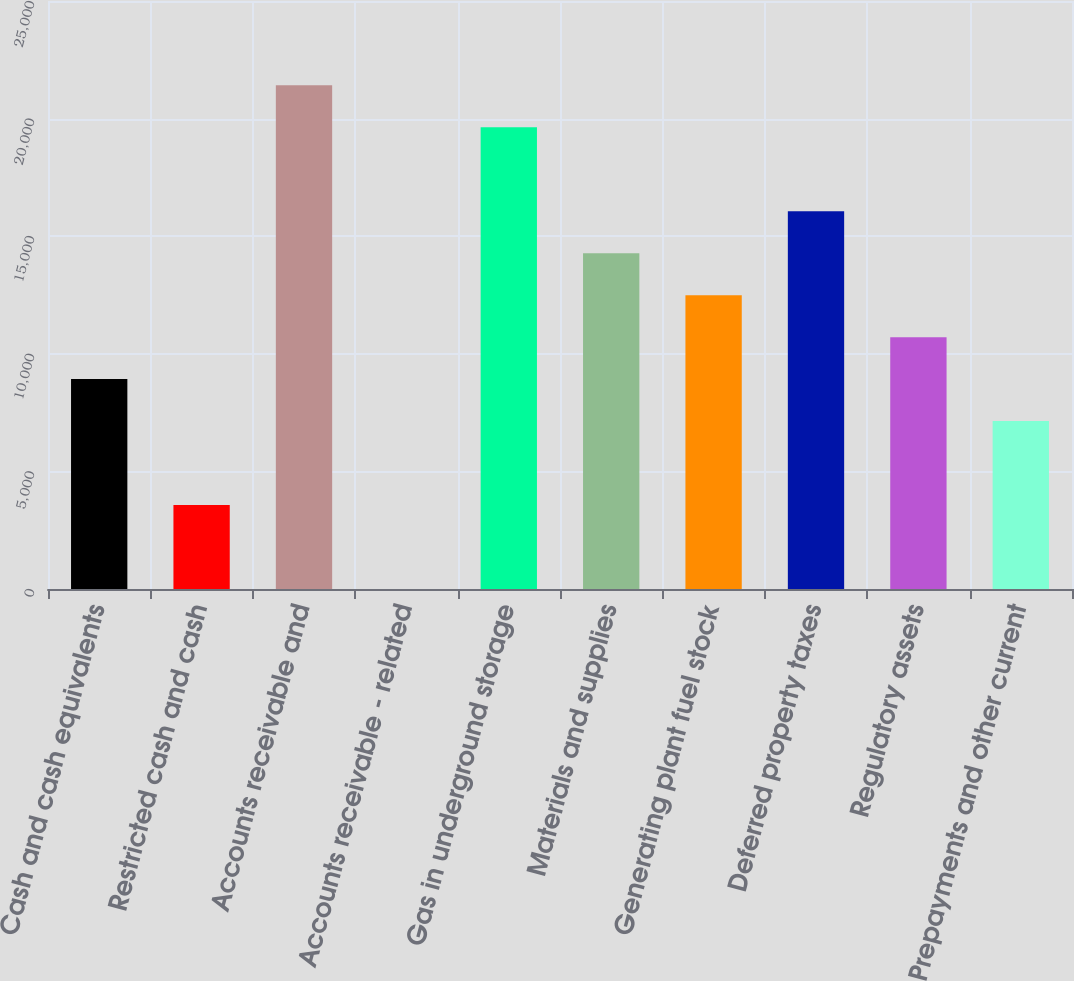Convert chart to OTSL. <chart><loc_0><loc_0><loc_500><loc_500><bar_chart><fcel>Cash and cash equivalents<fcel>Restricted cash and cash<fcel>Accounts receivable and<fcel>Accounts receivable - related<fcel>Gas in underground storage<fcel>Materials and supplies<fcel>Generating plant fuel stock<fcel>Deferred property taxes<fcel>Regulatory assets<fcel>Prepayments and other current<nl><fcel>8924<fcel>3570.2<fcel>21416.2<fcel>1<fcel>19631.6<fcel>14277.8<fcel>12493.2<fcel>16062.4<fcel>10708.6<fcel>7139.4<nl></chart> 